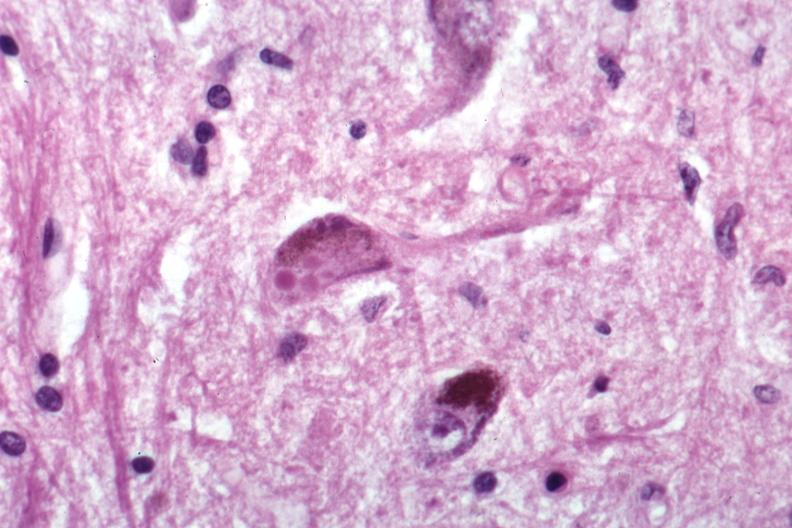s brain present?
Answer the question using a single word or phrase. Yes 